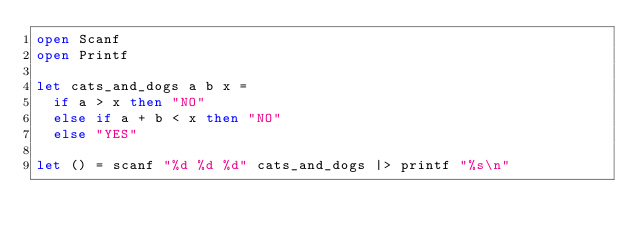<code> <loc_0><loc_0><loc_500><loc_500><_OCaml_>open Scanf
open Printf

let cats_and_dogs a b x =
  if a > x then "NO"
  else if a + b < x then "NO"
  else "YES"

let () = scanf "%d %d %d" cats_and_dogs |> printf "%s\n"</code> 